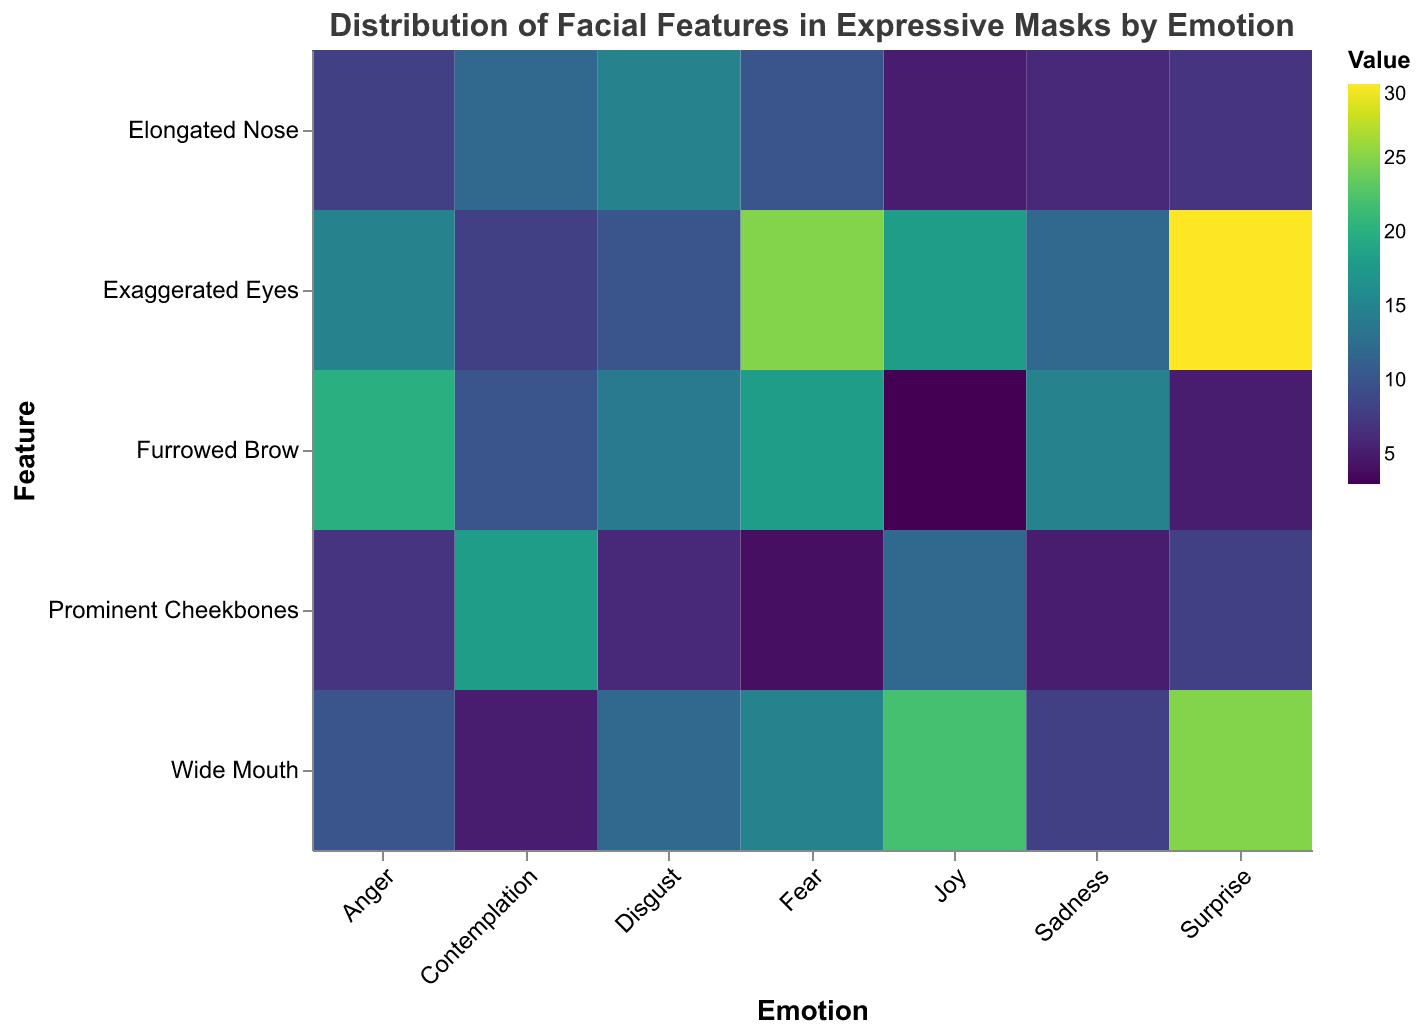What is the title of the figure? The title is usually located at the top of the figure. It provides a brief description of what the figure is about. Here it is "Distribution of Facial Features in Expressive Masks by Emotion".
Answer: Distribution of Facial Features in Expressive Masks by Emotion Which emotion has the highest use of “Exaggerated Eyes”? Look at the “Exaggerated Eyes” row and find the cell with the highest value. The color and size of the cell will also indicate the intensity.
Answer: Surprise What facial feature is most associated with "Anger"? Compare the values in the row corresponding to "Anger" across different facial features and identify which one has the highest value.
Answer: Furrowed Brow How many different emotions are displayed in the figure? Count the number of unique categories on the x-axis, which represents the emotions.
Answer: 7 What is the sum of values for “Furrowed Brow” across all emotions? Add up the values for "Furrowed Brow" in each emotion: 3 (Joy) + 20 (Anger) + 15 (Sadness) + 18 (Fear) + 5 (Surprise) + 14 (Disgust) + 10 (Contemplation).
Answer: 85 Which emotion has the least “Wide Mouth” feature represented? Look at the “Wide Mouth” row and find the cell with the lowest value. The color and size of the cell will indicate low intensity.
Answer: Contemplation Between “Sadness” and “Disgust,” which has more “Prominent Cheekbones”? Compare the values for "Prominent Cheekbones" in the "Sadness" and "Disgust" rows.
Answer: Disgust In which emotion is the “Elongated Nose” feature used the most frequently? Check the column for each emotion and see which one has the highest number for "Elongated Nose".
Answer: Disgust Is "Elongated Nose" more frequently used in masks portraying “Contemplation” or “Fear”? Compare the values for "Elongated Nose" in "Contemplation" and "Fear".
Answer: Fear What is the most common facial feature in masks expressing "Fear"? Look at the row for "Fear" and identify the facial feature with the highest value.
Answer: Exaggerated Eyes 